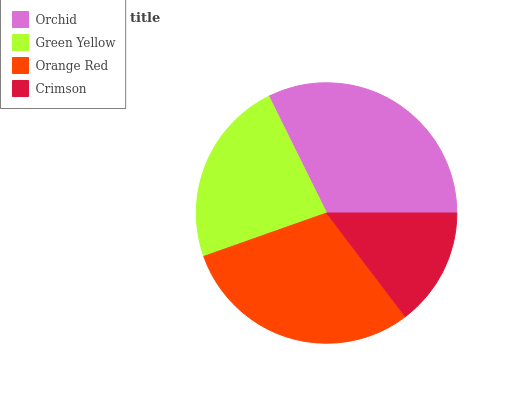Is Crimson the minimum?
Answer yes or no. Yes. Is Orchid the maximum?
Answer yes or no. Yes. Is Green Yellow the minimum?
Answer yes or no. No. Is Green Yellow the maximum?
Answer yes or no. No. Is Orchid greater than Green Yellow?
Answer yes or no. Yes. Is Green Yellow less than Orchid?
Answer yes or no. Yes. Is Green Yellow greater than Orchid?
Answer yes or no. No. Is Orchid less than Green Yellow?
Answer yes or no. No. Is Orange Red the high median?
Answer yes or no. Yes. Is Green Yellow the low median?
Answer yes or no. Yes. Is Crimson the high median?
Answer yes or no. No. Is Orange Red the low median?
Answer yes or no. No. 